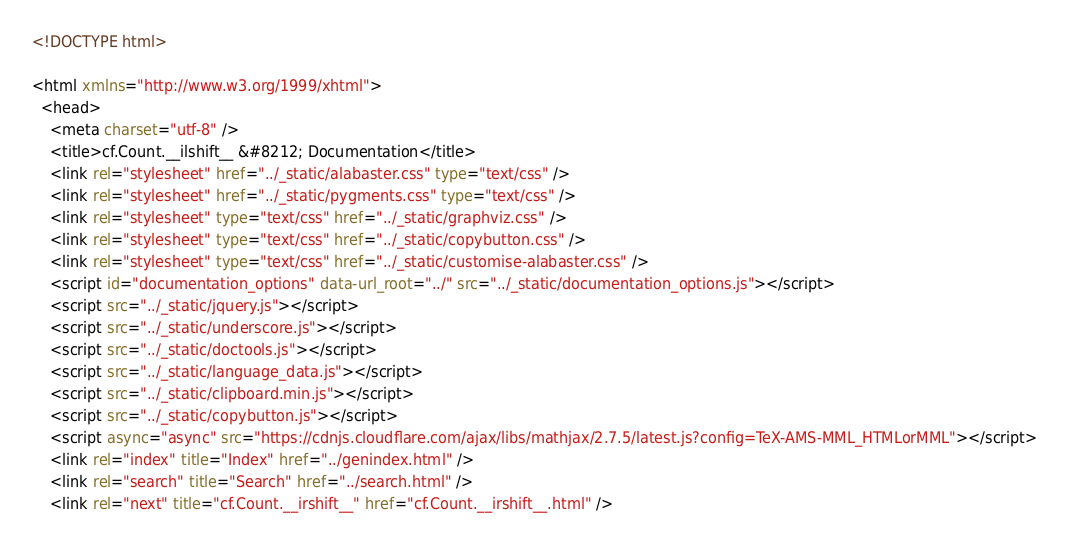Convert code to text. <code><loc_0><loc_0><loc_500><loc_500><_HTML_>
<!DOCTYPE html>

<html xmlns="http://www.w3.org/1999/xhtml">
  <head>
    <meta charset="utf-8" />
    <title>cf.Count.__ilshift__ &#8212; Documentation</title>
    <link rel="stylesheet" href="../_static/alabaster.css" type="text/css" />
    <link rel="stylesheet" href="../_static/pygments.css" type="text/css" />
    <link rel="stylesheet" type="text/css" href="../_static/graphviz.css" />
    <link rel="stylesheet" type="text/css" href="../_static/copybutton.css" />
    <link rel="stylesheet" type="text/css" href="../_static/customise-alabaster.css" />
    <script id="documentation_options" data-url_root="../" src="../_static/documentation_options.js"></script>
    <script src="../_static/jquery.js"></script>
    <script src="../_static/underscore.js"></script>
    <script src="../_static/doctools.js"></script>
    <script src="../_static/language_data.js"></script>
    <script src="../_static/clipboard.min.js"></script>
    <script src="../_static/copybutton.js"></script>
    <script async="async" src="https://cdnjs.cloudflare.com/ajax/libs/mathjax/2.7.5/latest.js?config=TeX-AMS-MML_HTMLorMML"></script>
    <link rel="index" title="Index" href="../genindex.html" />
    <link rel="search" title="Search" href="../search.html" />
    <link rel="next" title="cf.Count.__irshift__" href="cf.Count.__irshift__.html" /></code> 